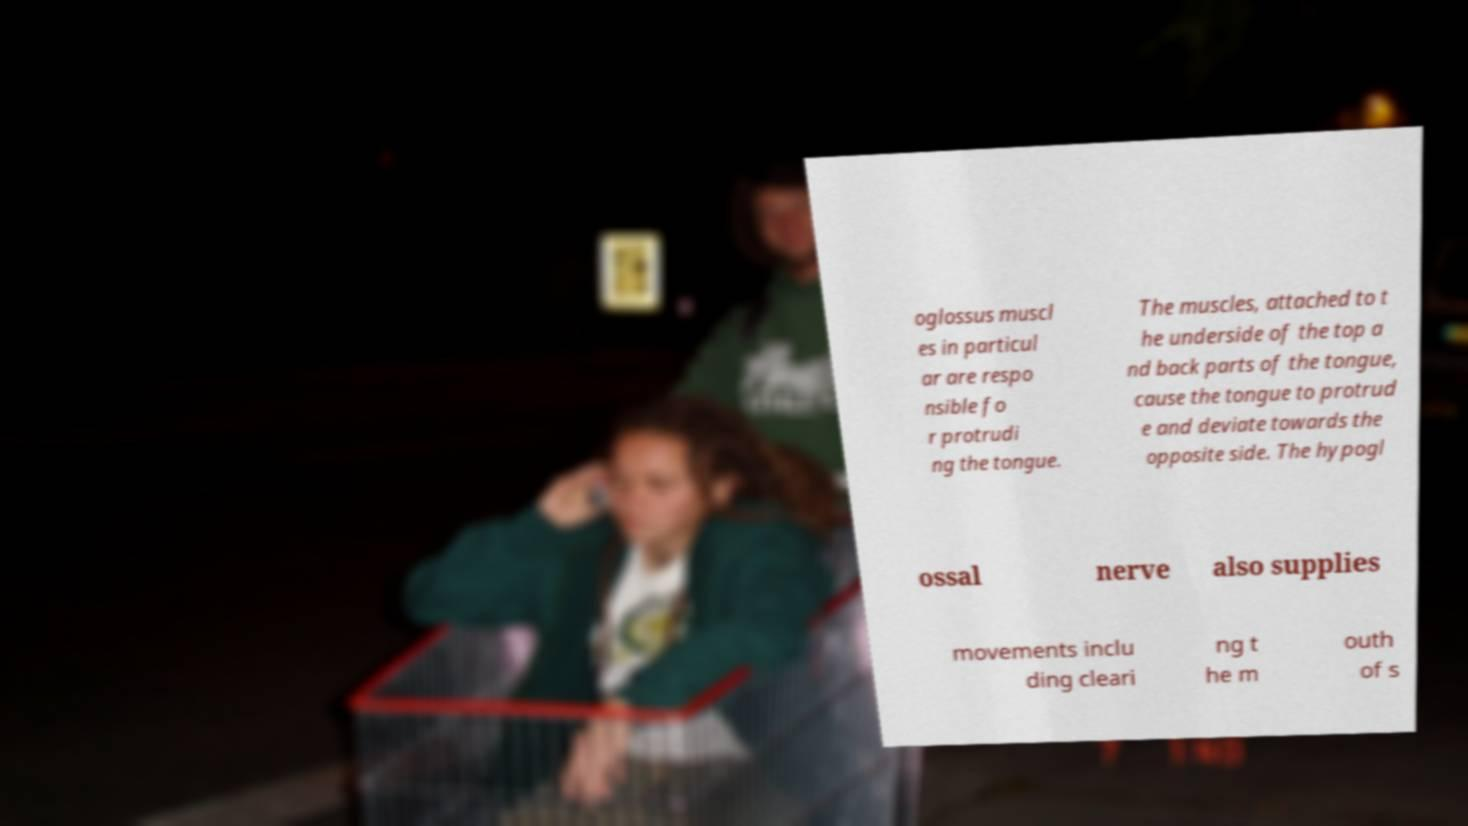Could you assist in decoding the text presented in this image and type it out clearly? oglossus muscl es in particul ar are respo nsible fo r protrudi ng the tongue. The muscles, attached to t he underside of the top a nd back parts of the tongue, cause the tongue to protrud e and deviate towards the opposite side. The hypogl ossal nerve also supplies movements inclu ding cleari ng t he m outh of s 